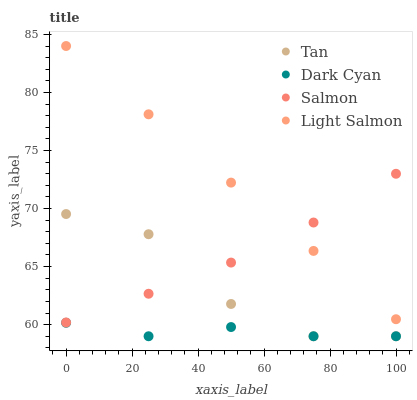Does Dark Cyan have the minimum area under the curve?
Answer yes or no. Yes. Does Light Salmon have the maximum area under the curve?
Answer yes or no. Yes. Does Tan have the minimum area under the curve?
Answer yes or no. No. Does Tan have the maximum area under the curve?
Answer yes or no. No. Is Light Salmon the smoothest?
Answer yes or no. Yes. Is Tan the roughest?
Answer yes or no. Yes. Is Salmon the smoothest?
Answer yes or no. No. Is Salmon the roughest?
Answer yes or no. No. Does Dark Cyan have the lowest value?
Answer yes or no. Yes. Does Salmon have the lowest value?
Answer yes or no. No. Does Light Salmon have the highest value?
Answer yes or no. Yes. Does Tan have the highest value?
Answer yes or no. No. Is Dark Cyan less than Salmon?
Answer yes or no. Yes. Is Light Salmon greater than Tan?
Answer yes or no. Yes. Does Salmon intersect Tan?
Answer yes or no. Yes. Is Salmon less than Tan?
Answer yes or no. No. Is Salmon greater than Tan?
Answer yes or no. No. Does Dark Cyan intersect Salmon?
Answer yes or no. No. 